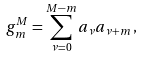<formula> <loc_0><loc_0><loc_500><loc_500>g _ { m } ^ { M } = \sum _ { \nu = 0 } ^ { M - m } a _ { \nu } a _ { \nu + m } \, ,</formula> 